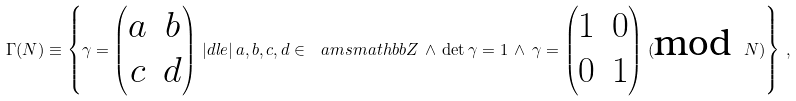Convert formula to latex. <formula><loc_0><loc_0><loc_500><loc_500>\Gamma ( N ) \equiv \left \{ \gamma = \begin{pmatrix} a & b \\ c & d \end{pmatrix} \, | d l e | \, a , b , c , d \in \ a m s m a t h b b { Z } \, \wedge \, \det \gamma = 1 \, \wedge \, \gamma = \begin{pmatrix} 1 & 0 \\ 0 & 1 \end{pmatrix} \, ( \text {mod } N ) \right \} \, ,</formula> 